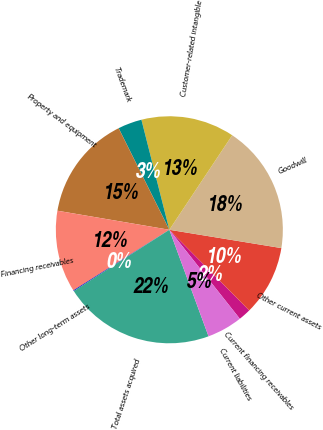<chart> <loc_0><loc_0><loc_500><loc_500><pie_chart><fcel>Current financing receivables<fcel>Other current assets<fcel>Goodwill<fcel>Customer-related intangible<fcel>Trademark<fcel>Property and equipment<fcel>Financing receivables<fcel>Other long-term assets<fcel>Total assets acquired<fcel>Current liabilities<nl><fcel>1.76%<fcel>10.0%<fcel>18.24%<fcel>13.3%<fcel>3.41%<fcel>14.95%<fcel>11.65%<fcel>0.11%<fcel>21.54%<fcel>5.05%<nl></chart> 